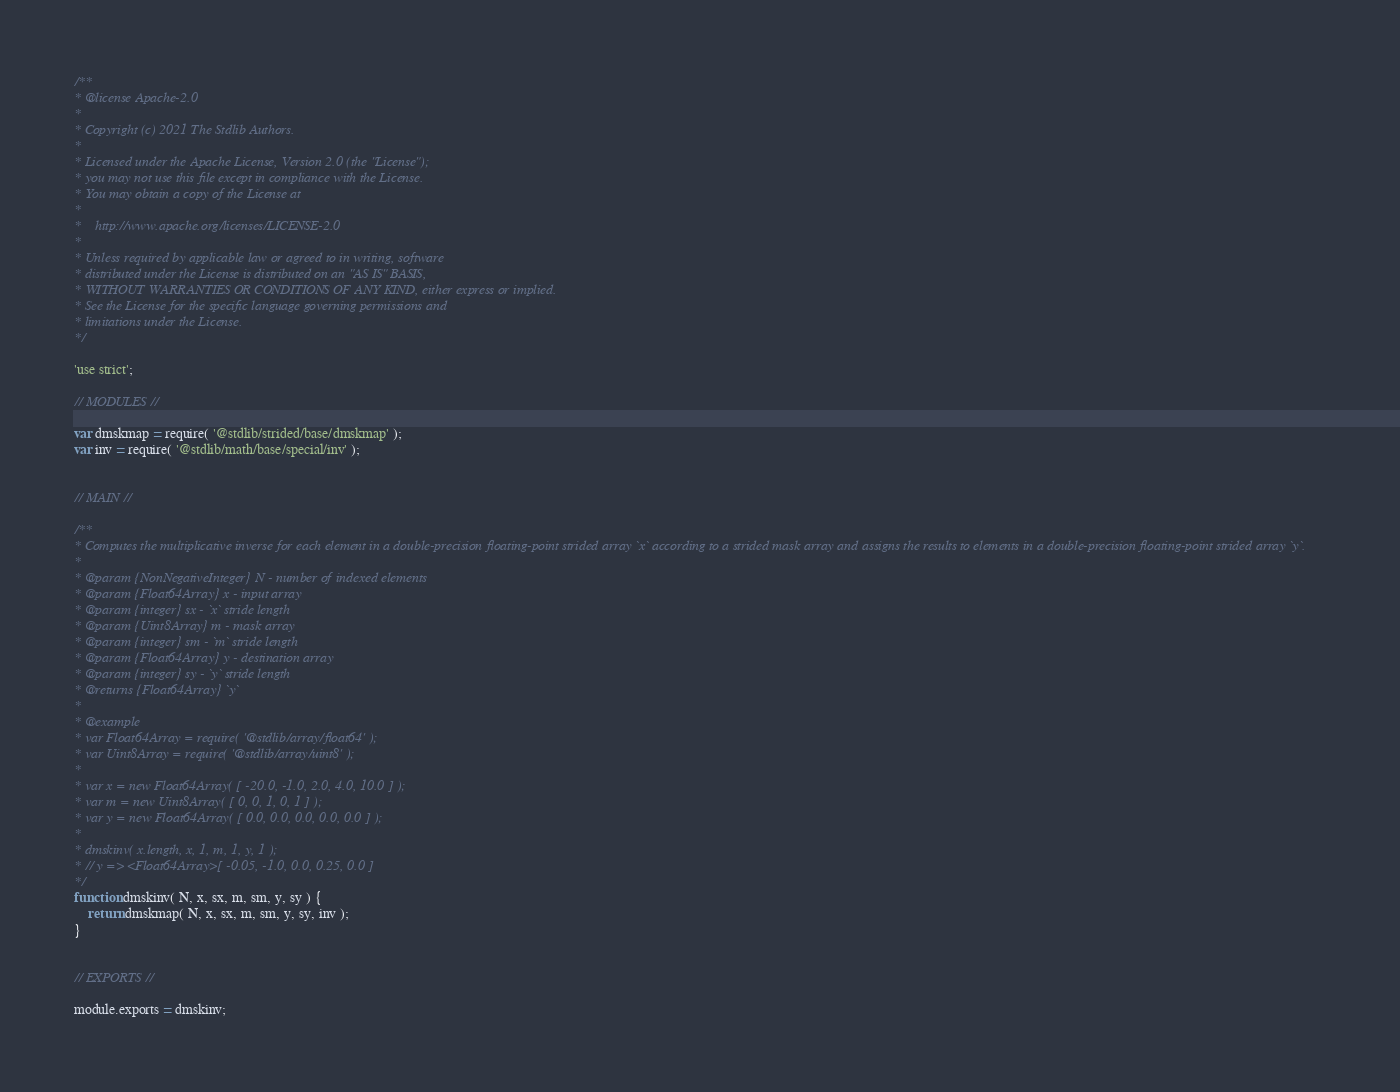Convert code to text. <code><loc_0><loc_0><loc_500><loc_500><_JavaScript_>/**
* @license Apache-2.0
*
* Copyright (c) 2021 The Stdlib Authors.
*
* Licensed under the Apache License, Version 2.0 (the "License");
* you may not use this file except in compliance with the License.
* You may obtain a copy of the License at
*
*    http://www.apache.org/licenses/LICENSE-2.0
*
* Unless required by applicable law or agreed to in writing, software
* distributed under the License is distributed on an "AS IS" BASIS,
* WITHOUT WARRANTIES OR CONDITIONS OF ANY KIND, either express or implied.
* See the License for the specific language governing permissions and
* limitations under the License.
*/

'use strict';

// MODULES //

var dmskmap = require( '@stdlib/strided/base/dmskmap' );
var inv = require( '@stdlib/math/base/special/inv' );


// MAIN //

/**
* Computes the multiplicative inverse for each element in a double-precision floating-point strided array `x` according to a strided mask array and assigns the results to elements in a double-precision floating-point strided array `y`.
*
* @param {NonNegativeInteger} N - number of indexed elements
* @param {Float64Array} x - input array
* @param {integer} sx - `x` stride length
* @param {Uint8Array} m - mask array
* @param {integer} sm - `m` stride length
* @param {Float64Array} y - destination array
* @param {integer} sy - `y` stride length
* @returns {Float64Array} `y`
*
* @example
* var Float64Array = require( '@stdlib/array/float64' );
* var Uint8Array = require( '@stdlib/array/uint8' );
*
* var x = new Float64Array( [ -20.0, -1.0, 2.0, 4.0, 10.0 ] );
* var m = new Uint8Array( [ 0, 0, 1, 0, 1 ] );
* var y = new Float64Array( [ 0.0, 0.0, 0.0, 0.0, 0.0 ] );
*
* dmskinv( x.length, x, 1, m, 1, y, 1 );
* // y => <Float64Array>[ -0.05, -1.0, 0.0, 0.25, 0.0 ]
*/
function dmskinv( N, x, sx, m, sm, y, sy ) {
	return dmskmap( N, x, sx, m, sm, y, sy, inv );
}


// EXPORTS //

module.exports = dmskinv;
</code> 